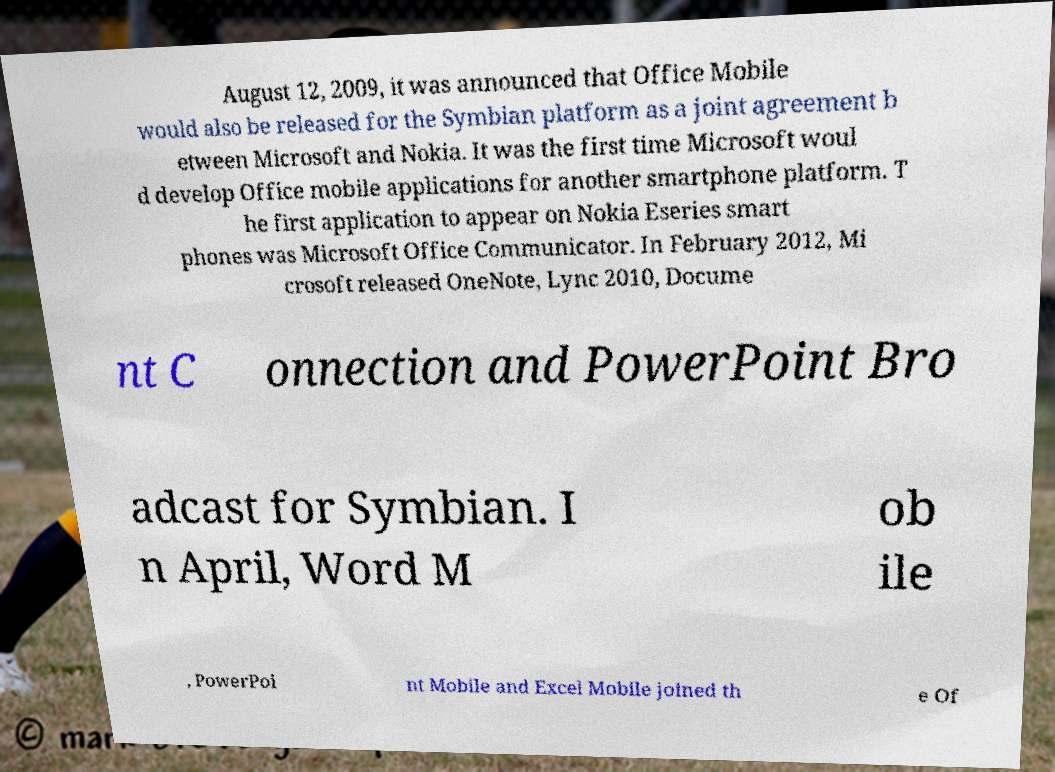Can you read and provide the text displayed in the image?This photo seems to have some interesting text. Can you extract and type it out for me? August 12, 2009, it was announced that Office Mobile would also be released for the Symbian platform as a joint agreement b etween Microsoft and Nokia. It was the first time Microsoft woul d develop Office mobile applications for another smartphone platform. T he first application to appear on Nokia Eseries smart phones was Microsoft Office Communicator. In February 2012, Mi crosoft released OneNote, Lync 2010, Docume nt C onnection and PowerPoint Bro adcast for Symbian. I n April, Word M ob ile , PowerPoi nt Mobile and Excel Mobile joined th e Of 